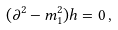<formula> <loc_0><loc_0><loc_500><loc_500>( \partial ^ { 2 } - m _ { 1 } ^ { 2 } ) h = 0 \, ,</formula> 